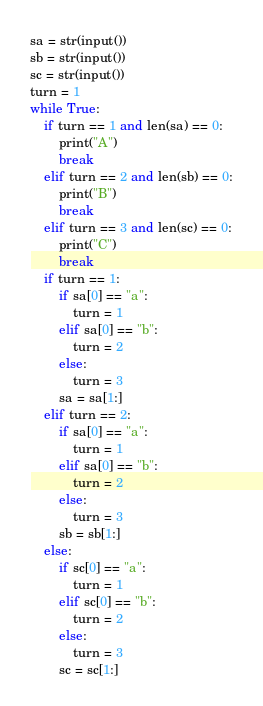Convert code to text. <code><loc_0><loc_0><loc_500><loc_500><_Python_>sa = str(input())
sb = str(input())
sc = str(input())
turn = 1
while True:
    if turn == 1 and len(sa) == 0:
        print("A")
        break
    elif turn == 2 and len(sb) == 0:
        print("B")
        break
    elif turn == 3 and len(sc) == 0:
        print("C")
        break
    if turn == 1:
        if sa[0] == "a":
            turn = 1
        elif sa[0] == "b":
            turn = 2
        else:
            turn = 3
        sa = sa[1:]
    elif turn == 2:
        if sa[0] == "a":
            turn = 1
        elif sa[0] == "b":
            turn = 2
        else:
            turn = 3
        sb = sb[1:]
    else:
        if sc[0] == "a":
            turn = 1
        elif sc[0] == "b":
            turn = 2
        else:
            turn = 3
        sc = sc[1:]</code> 